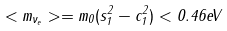Convert formula to latex. <formula><loc_0><loc_0><loc_500><loc_500>< m _ { \nu _ { e } } > = m _ { 0 } ( s _ { 1 } ^ { 2 } - c _ { 1 } ^ { 2 } ) < 0 . 4 6 e V</formula> 